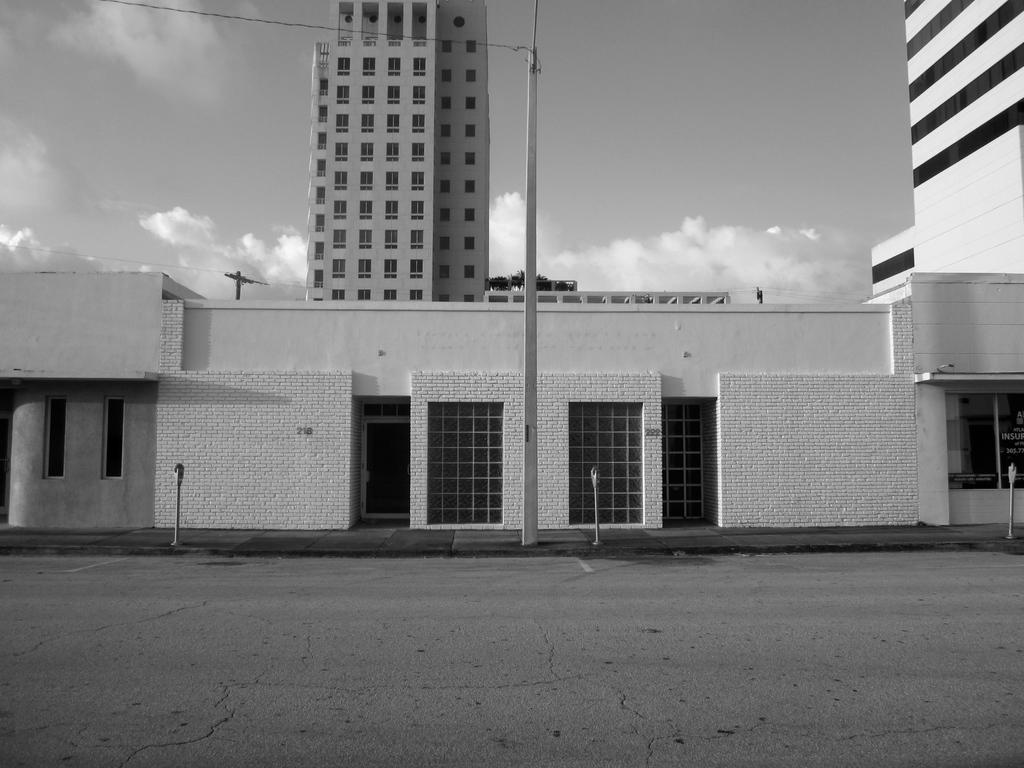What is the main feature of the image? There is a road in the image. What else can be seen along the road? There are poles, buildings, and wires in the image. What is visible in the background of the image? The sky is visible in the background of the image, and there are clouds in the sky. What type of thrill can be seen on the boy's face as he holds the bomb in the image? There is no boy or bomb present in the image; it features a road, poles, buildings, wires, and a sky with clouds. 